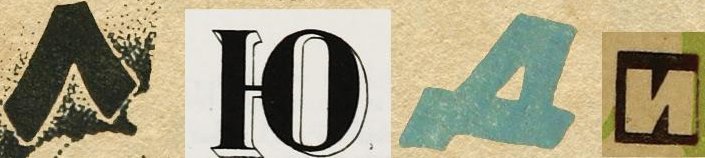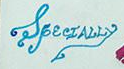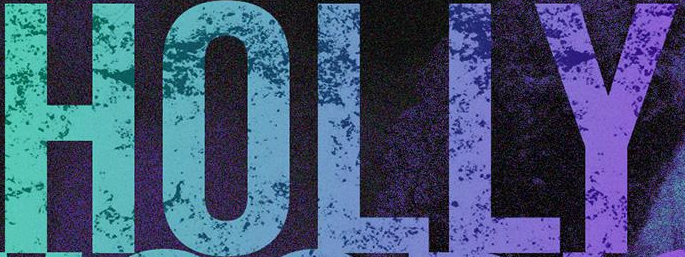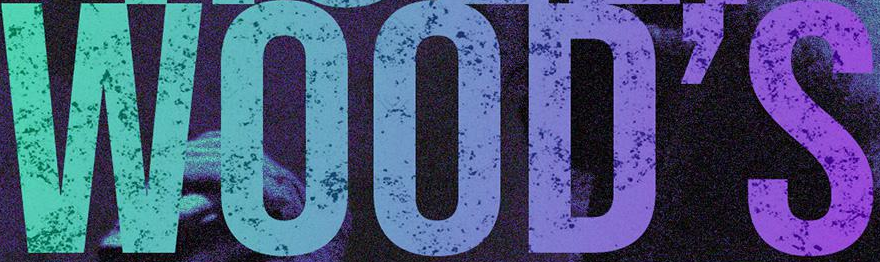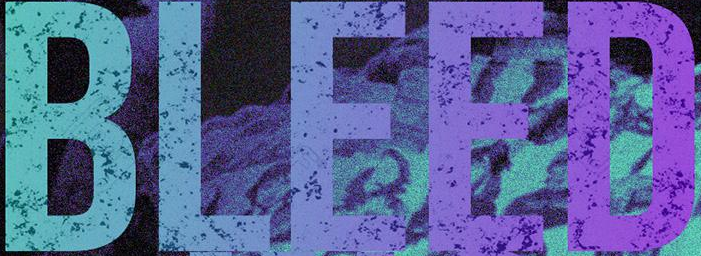What text is displayed in these images sequentially, separated by a semicolon? ####; SpecIALLy; HOLLY; WOOD'S; BLEED 